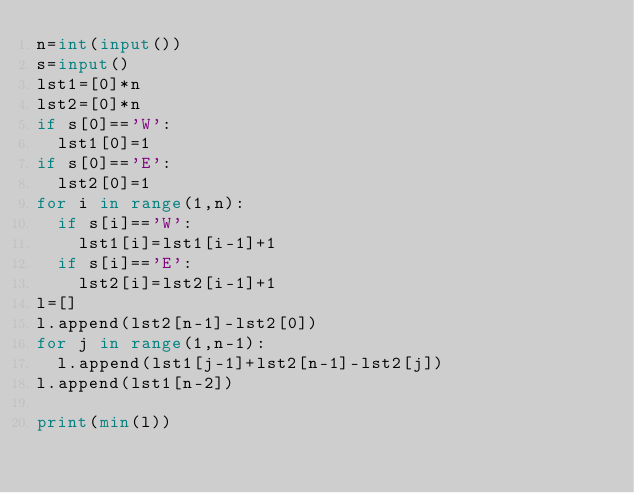Convert code to text. <code><loc_0><loc_0><loc_500><loc_500><_Python_>n=int(input())
s=input()
lst1=[0]*n
lst2=[0]*n
if s[0]=='W':
  lst1[0]=1
if s[0]=='E':
  lst2[0]=1
for i in range(1,n):
  if s[i]=='W':
    lst1[i]=lst1[i-1]+1
  if s[i]=='E':
    lst2[i]=lst2[i-1]+1
l=[]
l.append(lst2[n-1]-lst2[0])
for j in range(1,n-1):
  l.append(lst1[j-1]+lst2[n-1]-lst2[j])
l.append(lst1[n-2])

print(min(l))
  
  
</code> 